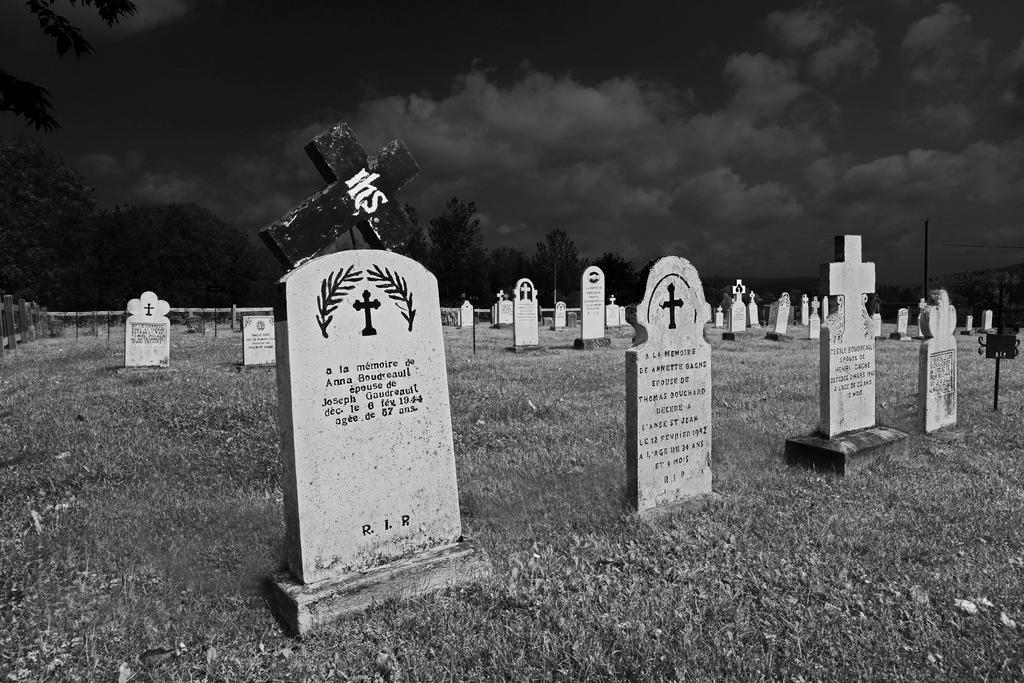Could you give a brief overview of what you see in this image? In this image we can see graveyard, trees and sky. 